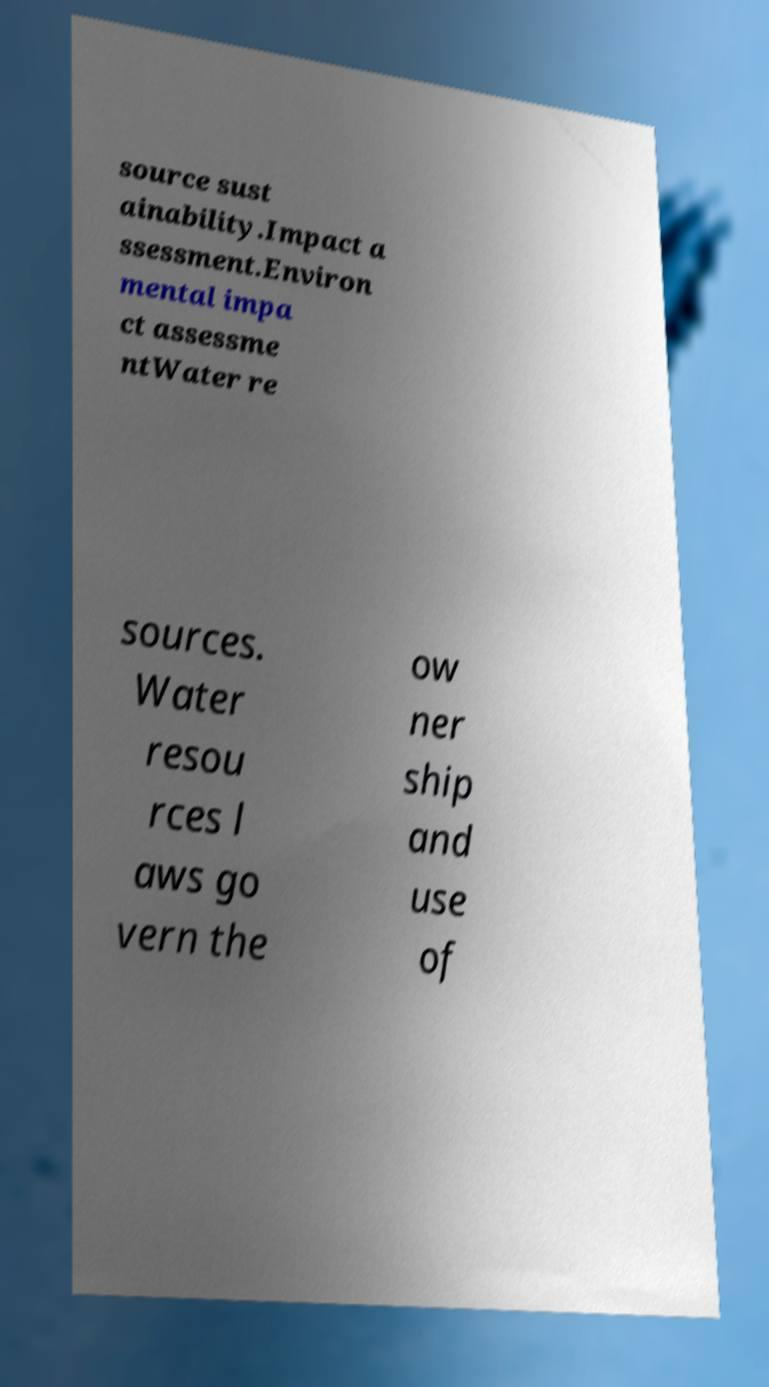I need the written content from this picture converted into text. Can you do that? source sust ainability.Impact a ssessment.Environ mental impa ct assessme ntWater re sources. Water resou rces l aws go vern the ow ner ship and use of 